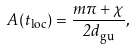<formula> <loc_0><loc_0><loc_500><loc_500>A ( t _ { \text {loc} } ) = \frac { m \pi + \chi } { 2 d _ { \text {gu} } } ,</formula> 